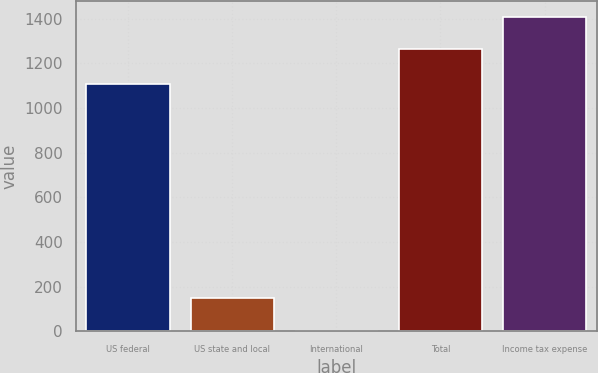Convert chart to OTSL. <chart><loc_0><loc_0><loc_500><loc_500><bar_chart><fcel>US federal<fcel>US state and local<fcel>International<fcel>Total<fcel>Income tax expense<nl><fcel>1109<fcel>149<fcel>4<fcel>1262<fcel>1408<nl></chart> 